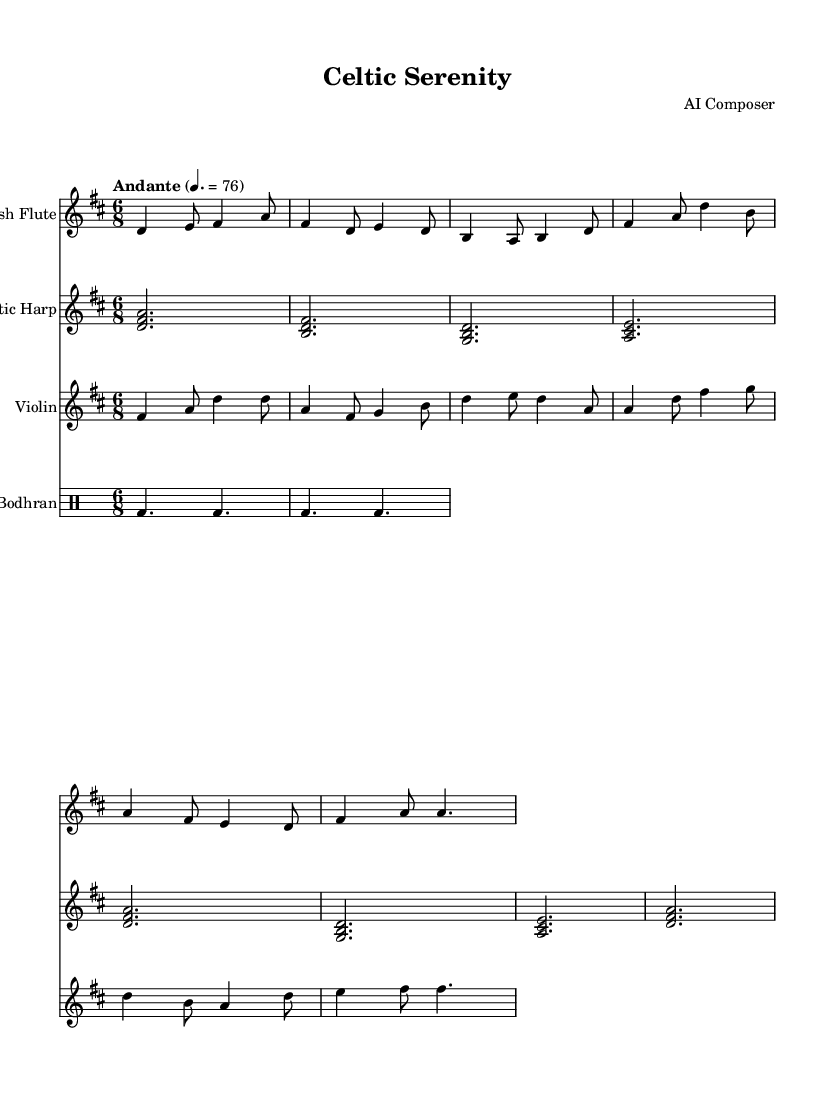What is the title of this piece? The title is found at the top of the sheet music, clearly marked as "Celtic Serenity."
Answer: Celtic Serenity What is the key signature of this music? The key signature is indicated by the key signature emblem at the beginning of the piece, which shows two sharps (F# and C#), signifying it's in D major.
Answer: D major What is the time signature of this music? The time signature is displayed at the beginning of the sheet music, showing that there are six beats in a measure and the eighth note gets the beat, which is represented as 6/8.
Answer: 6/8 What is the tempo marking for this music? The tempo marking written above the staff specifies that the piece should be played "Andante," with a metronome marking of 76 beats per minute.
Answer: Andante How many instruments are used in this piece? By examining the score, it is evident that there are four distinct staves, each representing a different instrument: the Irish Flute, Celtic Harp, Violin, and Bodhran.
Answer: Four What is the most prominent instrumental texture in this music? The arrangement shows a combination of melodic and harmonic parts, with the flute and violin often carrying the melody while the harp provides harmonic support, creating a homophonic texture that is characteristic of Celtic music.
Answer: Homophonic Which instrument primarily plays the rhythm in this piece? The rhythm is chiefly maintained by the Bodhran, a traditional Irish frame drum, which is explicitly notated to keep the pulse throughout the music.
Answer: Bodhran 